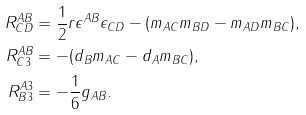<formula> <loc_0><loc_0><loc_500><loc_500>R ^ { A B } _ { C D } & = \frac { 1 } { 2 } r \epsilon ^ { A B } \epsilon _ { C D } - ( m _ { A C } m _ { B D } - m _ { A D } m _ { B C } ) , \\ R ^ { A B } _ { C 3 } & = - ( d _ { B } m _ { A C } - d _ { A } m _ { B C } ) , \\ R ^ { A 3 } _ { B 3 } & = - \frac { 1 } { 6 } g _ { A B } .</formula> 